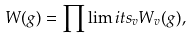<formula> <loc_0><loc_0><loc_500><loc_500>W ( g ) = \prod \lim i t s _ { v } W _ { v } ( g ) ,</formula> 